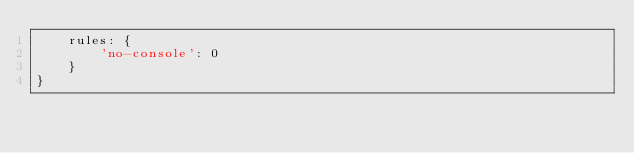<code> <loc_0><loc_0><loc_500><loc_500><_JavaScript_>    rules: {
        'no-console': 0
    }
}
</code> 